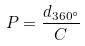<formula> <loc_0><loc_0><loc_500><loc_500>P = \frac { d _ { 3 6 0 ^ { \circ } } } { C }</formula> 